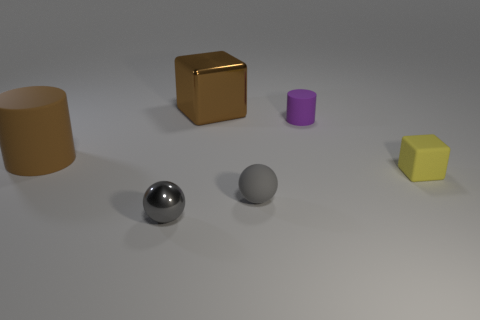Add 2 small brown metal objects. How many objects exist? 8 Subtract all cubes. How many objects are left? 4 Subtract all big metallic blocks. Subtract all big purple metal cylinders. How many objects are left? 5 Add 2 tiny rubber cylinders. How many tiny rubber cylinders are left? 3 Add 6 tiny purple objects. How many tiny purple objects exist? 7 Subtract 0 green cylinders. How many objects are left? 6 